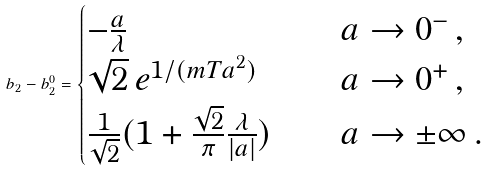Convert formula to latex. <formula><loc_0><loc_0><loc_500><loc_500>b _ { 2 } - b ^ { 0 } _ { 2 } = \begin{cases} - \frac { a } { \lambda } & \quad a \rightarrow 0 ^ { - } \, , \\ \sqrt { 2 } \, e ^ { 1 / ( m T a ^ { 2 } ) } & \quad a \rightarrow 0 ^ { + } \, , \\ \frac { 1 } { \sqrt { 2 } } ( 1 + \frac { \sqrt { 2 } } { \pi } \frac { \lambda } { | a | } ) & \quad a \rightarrow \pm \infty \, . \end{cases}</formula> 